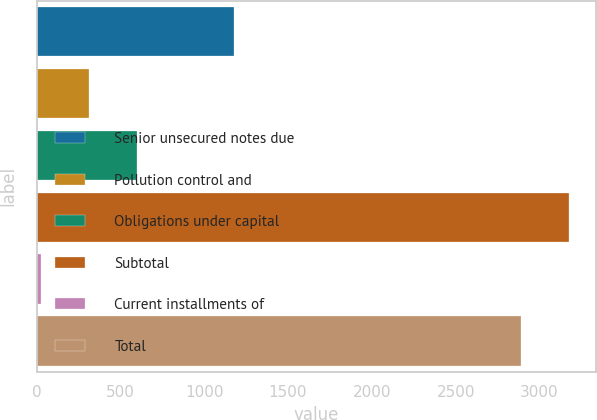Convert chart to OTSL. <chart><loc_0><loc_0><loc_500><loc_500><bar_chart><fcel>Senior unsecured notes due<fcel>Pollution control and<fcel>Obligations under capital<fcel>Subtotal<fcel>Current installments of<fcel>Total<nl><fcel>1178.8<fcel>312.7<fcel>601.4<fcel>3175.7<fcel>24<fcel>2887<nl></chart> 